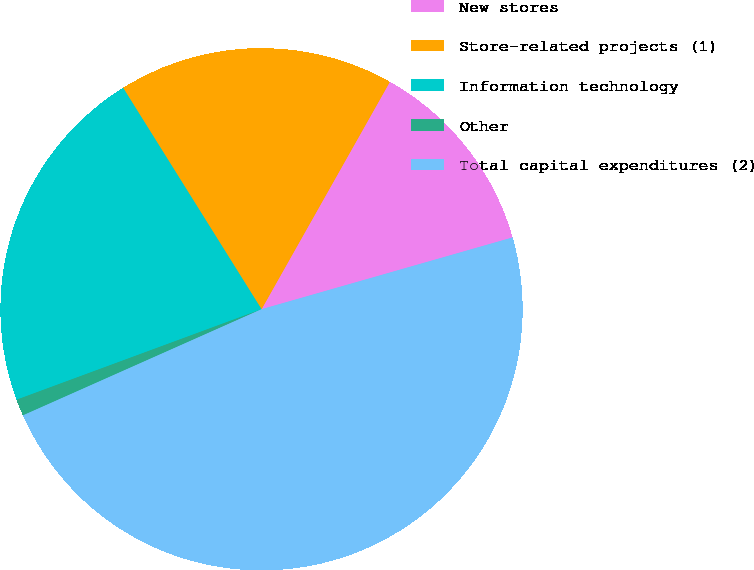<chart> <loc_0><loc_0><loc_500><loc_500><pie_chart><fcel>New stores<fcel>Store-related projects (1)<fcel>Information technology<fcel>Other<fcel>Total capital expenditures (2)<nl><fcel>12.39%<fcel>17.07%<fcel>21.74%<fcel>1.03%<fcel>47.77%<nl></chart> 